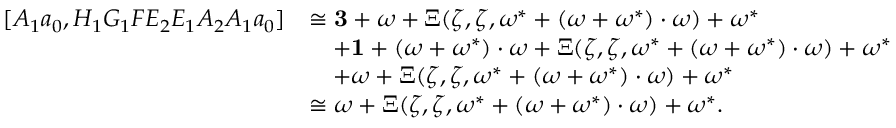Convert formula to latex. <formula><loc_0><loc_0><loc_500><loc_500>\begin{array} { r l } { [ A _ { 1 } a _ { 0 } , H _ { 1 } G _ { 1 } F E _ { 2 } E _ { 1 } A _ { 2 } A _ { 1 } a _ { 0 } ] } & { \cong \mathbf 3 + \omega + \Xi ( \zeta , \zeta , \omega ^ { * } + ( \omega + \omega ^ { * } ) \cdot \omega ) + \omega ^ { * } } \\ & { \quad + \mathbf 1 + ( \omega + \omega ^ { * } ) \cdot \omega + \Xi ( \zeta , \zeta , \omega ^ { * } + ( \omega + \omega ^ { * } ) \cdot \omega ) + \omega ^ { * } } \\ & { \quad + \omega + \Xi ( \zeta , \zeta , \omega ^ { * } + ( \omega + \omega ^ { * } ) \cdot \omega ) + \omega ^ { * } } \\ & { \cong \omega + \Xi ( \zeta , \zeta , \omega ^ { * } + ( \omega + \omega ^ { * } ) \cdot \omega ) + \omega ^ { * } . } \end{array}</formula> 